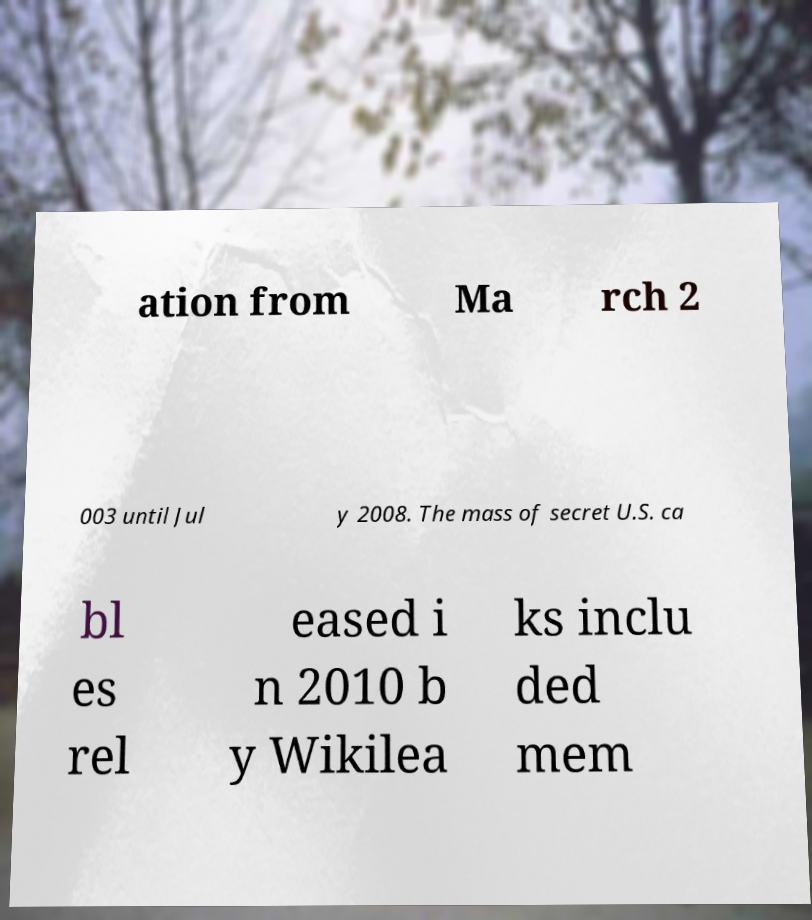What messages or text are displayed in this image? I need them in a readable, typed format. ation from Ma rch 2 003 until Jul y 2008. The mass of secret U.S. ca bl es rel eased i n 2010 b y Wikilea ks inclu ded mem 